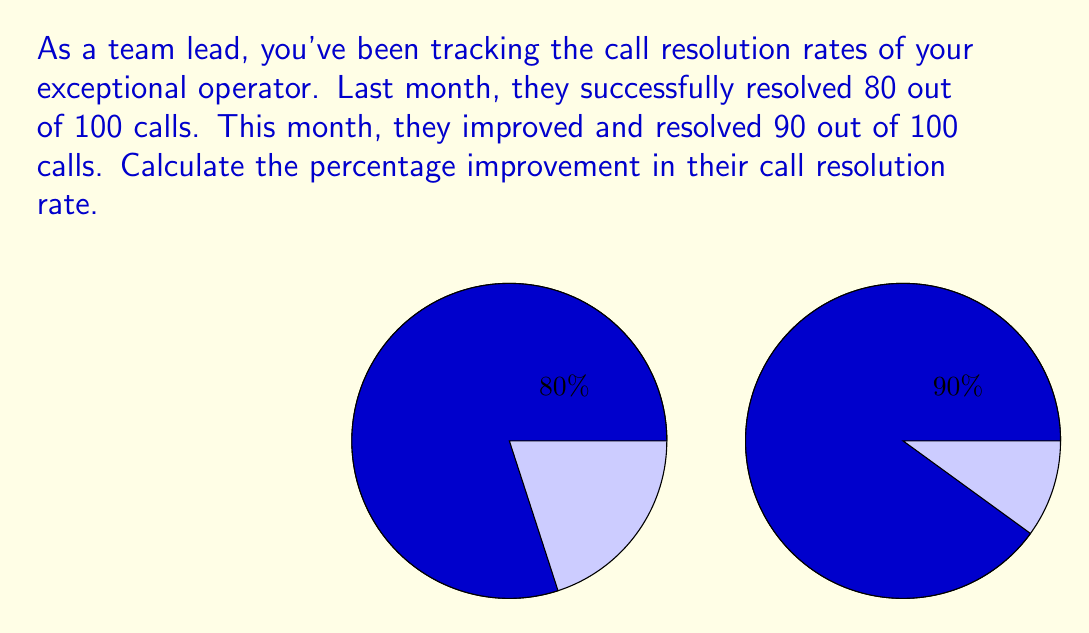Show me your answer to this math problem. Let's approach this step-by-step:

1) First, let's calculate the initial call resolution rate:
   $\text{Initial rate} = \frac{80}{100} = 0.80 = 80\%$

2) Now, let's calculate the new call resolution rate:
   $\text{New rate} = \frac{90}{100} = 0.90 = 90\%$

3) To find the improvement, we subtract the initial rate from the new rate:
   $\text{Improvement} = 90\% - 80\% = 10\%$

4) However, we need to express this as a percentage improvement relative to the initial rate. We can do this by dividing the improvement by the initial rate and multiplying by 100:

   $$\text{Percentage improvement} = \frac{\text{Improvement}}{\text{Initial rate}} \times 100\%$$

   $$= \frac{0.10}{0.80} \times 100\% = 0.125 \times 100\% = 12.5\%$$

Therefore, the percentage improvement in the call resolution rate is 12.5%.
Answer: $12.5\%$ 